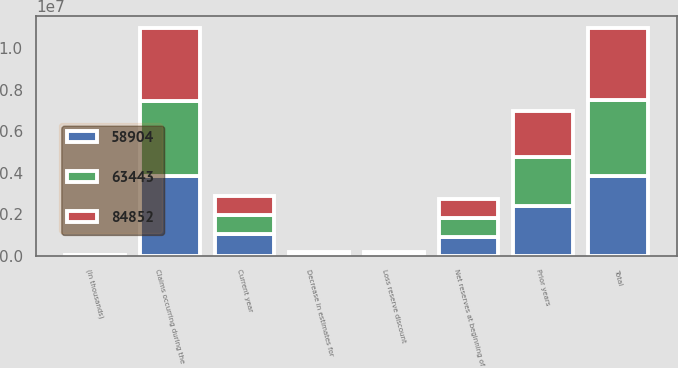<chart> <loc_0><loc_0><loc_500><loc_500><stacked_bar_chart><ecel><fcel>(In thousands)<fcel>Net reserves at beginning of<fcel>Claims occurring during the<fcel>Decrease in estimates for<fcel>Loss reserve discount<fcel>Total<fcel>Current year<fcel>Prior years<nl><fcel>58904<fcel>2016<fcel>914637<fcel>3.82662e+06<fcel>29904<fcel>49084<fcel>3.8458e+06<fcel>1.05245e+06<fcel>2.40172e+06<nl><fcel>63443<fcel>2015<fcel>914637<fcel>3.65356e+06<fcel>46713<fcel>49422<fcel>3.65627e+06<fcel>914637<fcel>2.34238e+06<nl><fcel>84852<fcel>2014<fcel>914637<fcel>3.49582e+06<fcel>75764<fcel>70506<fcel>3.49057e+06<fcel>898944<fcel>2.21628e+06<nl></chart> 